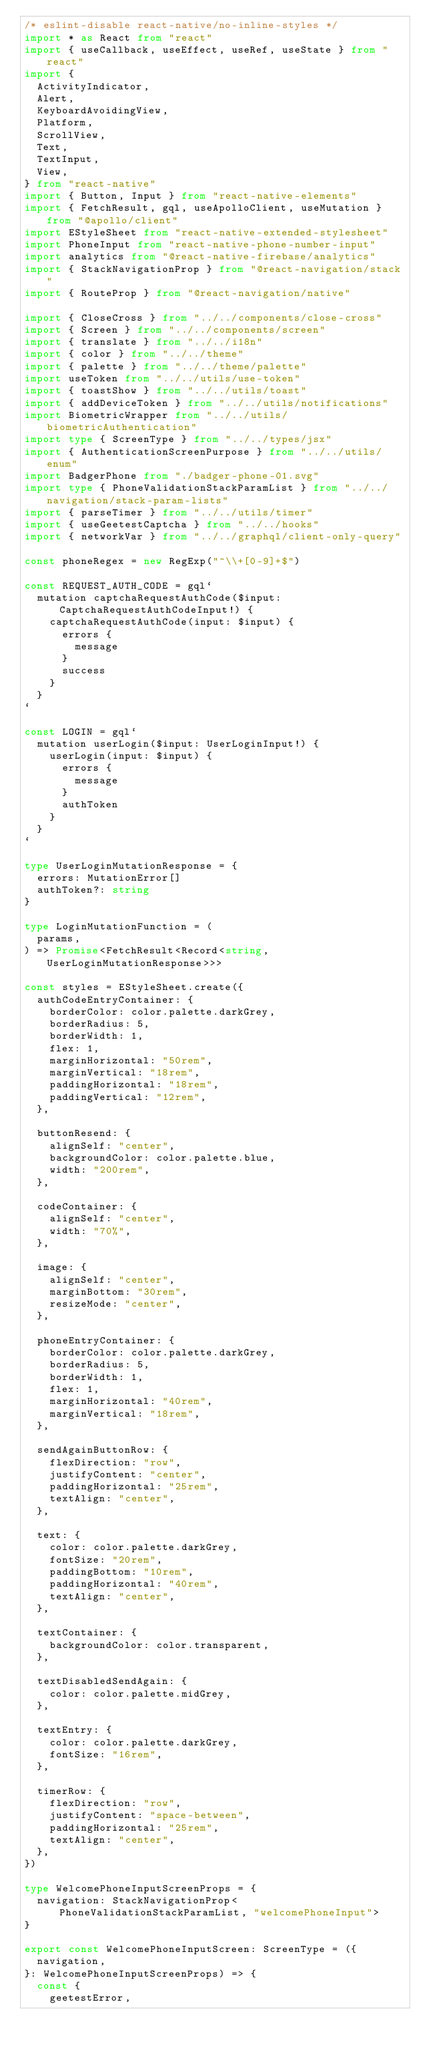Convert code to text. <code><loc_0><loc_0><loc_500><loc_500><_TypeScript_>/* eslint-disable react-native/no-inline-styles */
import * as React from "react"
import { useCallback, useEffect, useRef, useState } from "react"
import {
  ActivityIndicator,
  Alert,
  KeyboardAvoidingView,
  Platform,
  ScrollView,
  Text,
  TextInput,
  View,
} from "react-native"
import { Button, Input } from "react-native-elements"
import { FetchResult, gql, useApolloClient, useMutation } from "@apollo/client"
import EStyleSheet from "react-native-extended-stylesheet"
import PhoneInput from "react-native-phone-number-input"
import analytics from "@react-native-firebase/analytics"
import { StackNavigationProp } from "@react-navigation/stack"
import { RouteProp } from "@react-navigation/native"

import { CloseCross } from "../../components/close-cross"
import { Screen } from "../../components/screen"
import { translate } from "../../i18n"
import { color } from "../../theme"
import { palette } from "../../theme/palette"
import useToken from "../../utils/use-token"
import { toastShow } from "../../utils/toast"
import { addDeviceToken } from "../../utils/notifications"
import BiometricWrapper from "../../utils/biometricAuthentication"
import type { ScreenType } from "../../types/jsx"
import { AuthenticationScreenPurpose } from "../../utils/enum"
import BadgerPhone from "./badger-phone-01.svg"
import type { PhoneValidationStackParamList } from "../../navigation/stack-param-lists"
import { parseTimer } from "../../utils/timer"
import { useGeetestCaptcha } from "../../hooks"
import { networkVar } from "../../graphql/client-only-query"

const phoneRegex = new RegExp("^\\+[0-9]+$")

const REQUEST_AUTH_CODE = gql`
  mutation captchaRequestAuthCode($input: CaptchaRequestAuthCodeInput!) {
    captchaRequestAuthCode(input: $input) {
      errors {
        message
      }
      success
    }
  }
`

const LOGIN = gql`
  mutation userLogin($input: UserLoginInput!) {
    userLogin(input: $input) {
      errors {
        message
      }
      authToken
    }
  }
`

type UserLoginMutationResponse = {
  errors: MutationError[]
  authToken?: string
}

type LoginMutationFunction = (
  params,
) => Promise<FetchResult<Record<string, UserLoginMutationResponse>>>

const styles = EStyleSheet.create({
  authCodeEntryContainer: {
    borderColor: color.palette.darkGrey,
    borderRadius: 5,
    borderWidth: 1,
    flex: 1,
    marginHorizontal: "50rem",
    marginVertical: "18rem",
    paddingHorizontal: "18rem",
    paddingVertical: "12rem",
  },

  buttonResend: {
    alignSelf: "center",
    backgroundColor: color.palette.blue,
    width: "200rem",
  },

  codeContainer: {
    alignSelf: "center",
    width: "70%",
  },

  image: {
    alignSelf: "center",
    marginBottom: "30rem",
    resizeMode: "center",
  },

  phoneEntryContainer: {
    borderColor: color.palette.darkGrey,
    borderRadius: 5,
    borderWidth: 1,
    flex: 1,
    marginHorizontal: "40rem",
    marginVertical: "18rem",
  },

  sendAgainButtonRow: {
    flexDirection: "row",
    justifyContent: "center",
    paddingHorizontal: "25rem",
    textAlign: "center",
  },

  text: {
    color: color.palette.darkGrey,
    fontSize: "20rem",
    paddingBottom: "10rem",
    paddingHorizontal: "40rem",
    textAlign: "center",
  },

  textContainer: {
    backgroundColor: color.transparent,
  },

  textDisabledSendAgain: {
    color: color.palette.midGrey,
  },

  textEntry: {
    color: color.palette.darkGrey,
    fontSize: "16rem",
  },

  timerRow: {
    flexDirection: "row",
    justifyContent: "space-between",
    paddingHorizontal: "25rem",
    textAlign: "center",
  },
})

type WelcomePhoneInputScreenProps = {
  navigation: StackNavigationProp<PhoneValidationStackParamList, "welcomePhoneInput">
}

export const WelcomePhoneInputScreen: ScreenType = ({
  navigation,
}: WelcomePhoneInputScreenProps) => {
  const {
    geetestError,</code> 